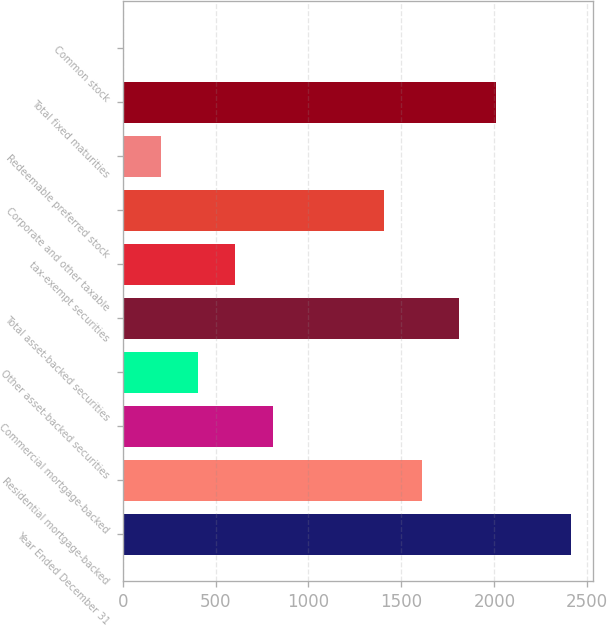Convert chart to OTSL. <chart><loc_0><loc_0><loc_500><loc_500><bar_chart><fcel>Year Ended December 31<fcel>Residential mortgage-backed<fcel>Commercial mortgage-backed<fcel>Other asset-backed securities<fcel>Total asset-backed securities<fcel>tax-exempt securities<fcel>Corporate and other taxable<fcel>Redeemable preferred stock<fcel>Total fixed maturities<fcel>Common stock<nl><fcel>2409.8<fcel>1608.2<fcel>806.6<fcel>405.8<fcel>1808.6<fcel>606.2<fcel>1407.8<fcel>205.4<fcel>2009<fcel>5<nl></chart> 